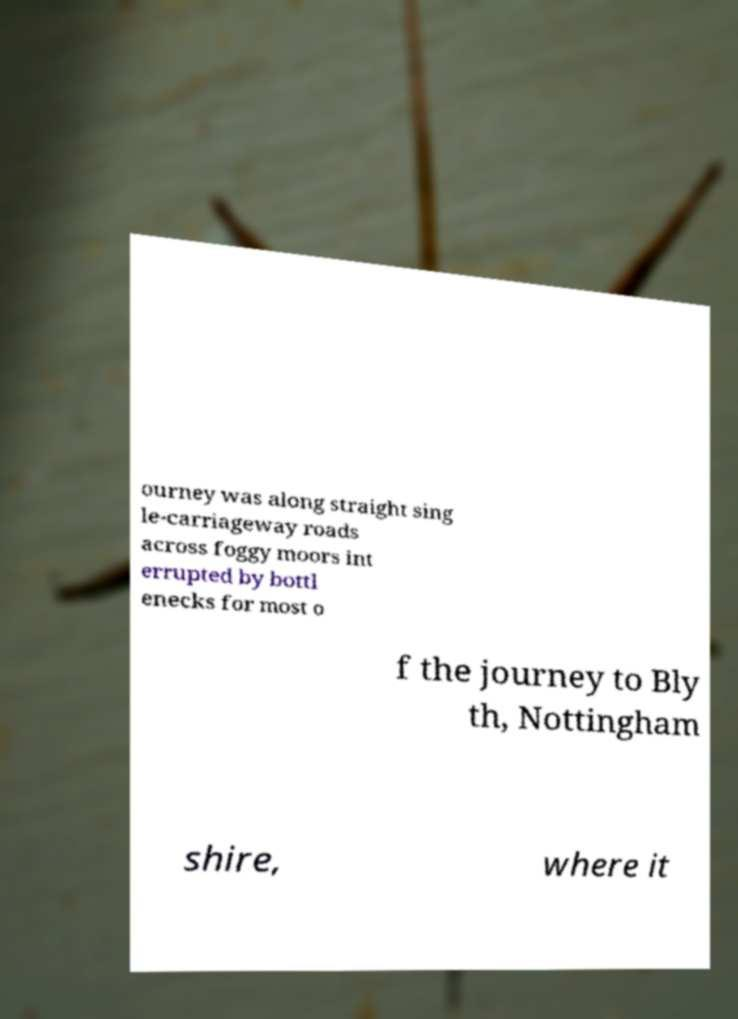For documentation purposes, I need the text within this image transcribed. Could you provide that? ourney was along straight sing le-carriageway roads across foggy moors int errupted by bottl enecks for most o f the journey to Bly th, Nottingham shire, where it 